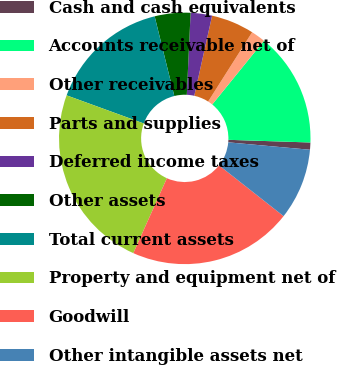Convert chart to OTSL. <chart><loc_0><loc_0><loc_500><loc_500><pie_chart><fcel>Cash and cash equivalents<fcel>Accounts receivable net of<fcel>Other receivables<fcel>Parts and supplies<fcel>Deferred income taxes<fcel>Other assets<fcel>Total current assets<fcel>Property and equipment net of<fcel>Goodwill<fcel>Other intangible assets net<nl><fcel>0.92%<fcel>14.68%<fcel>1.84%<fcel>5.51%<fcel>2.75%<fcel>4.59%<fcel>15.59%<fcel>23.85%<fcel>21.1%<fcel>9.17%<nl></chart> 